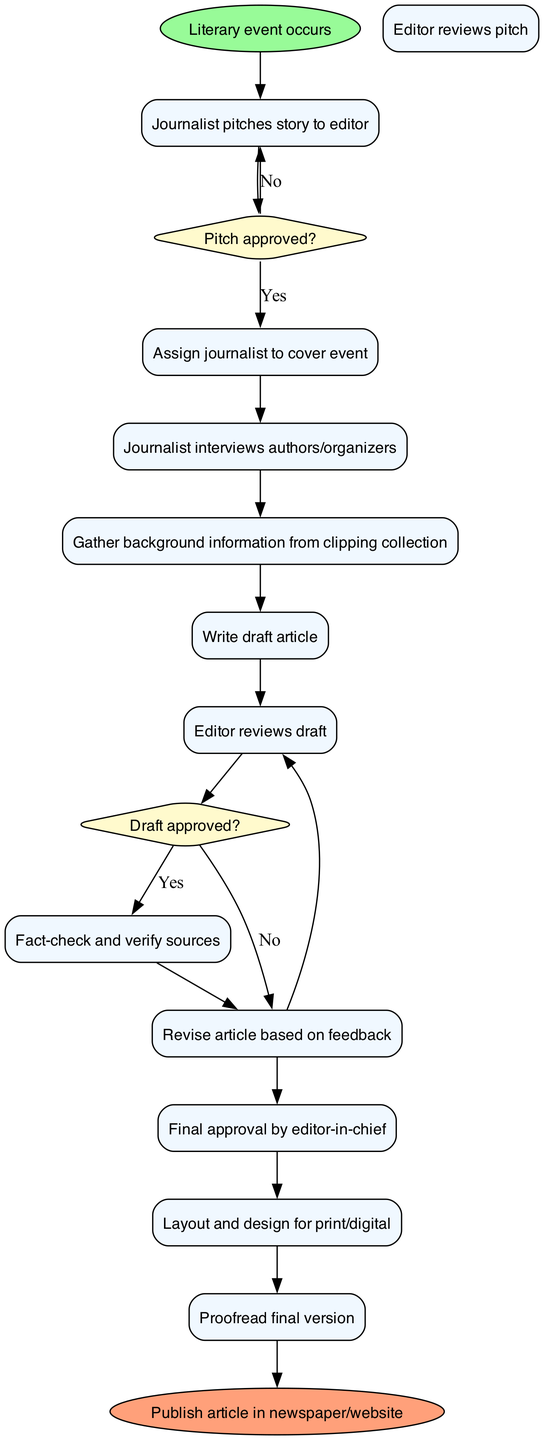What is the first activity in the diagram? The first activity is directly connected to the start node. According to the diagram, the first activity listed is "Journalist pitches story to editor."
Answer: Journalist pitches story to editor How many activities are there in total? The diagram lists a total of 12 activities from the start to just before the end node. Counting each listed activity, there are 12 activities present.
Answer: 12 What occurs after the editor reviews the pitch? After the editor reviews the pitch, there is a decision point depicted in the diagram. If the pitch is approved (yes), the next activity is "Assign journalist to cover event." If it is not approved (no), the flow loops back to "Journalist pitches story to editor."
Answer: Assign journalist to cover event / Journalist pitches story to editor (two options) What is the final node of the diagram? The final node is the endpoint of the workflow depicted in the diagram, indicating the completion of the lifecycle. According to the diagram, the final node is "Publish article in newspaper/website."
Answer: Publish article in newspaper/website What happens if the draft is not approved? The diagram specifies that if the draft is not approved, the next action is to "Revise article based on feedback." This is achieved through the decision point for draft approval.
Answer: Revise article based on feedback How many decision nodes are shown in the diagram? The diagram includes decision nodes that determine the next steps in the workflow. There are two decision nodes based on the conditions of pitch and draft approvals.
Answer: 2 What activity follows the fact-checking and verification of sources? After the activity of fact-checking and verifying sources is completed, the next activity in the sequence is "Revise article based on feedback," contingent upon draft approval.
Answer: Revise article based on feedback What is the condition that leads to assigning a journalist to cover the event? The condition leading to assigning a journalist occurs when the pitch is approved. If the answer to "Pitch approved?" is yes, then the next action is to "Assign journalist to cover event."
Answer: Pitch approved? What is the role of the editor-in-chief in this lifecycle? The editor-in-chief is responsible for giving the final approval of the article after the editor's review and necessary revisions. This indicates the importance of their role in the publication lifecycle.
Answer: Final approval by editor-in-chief 